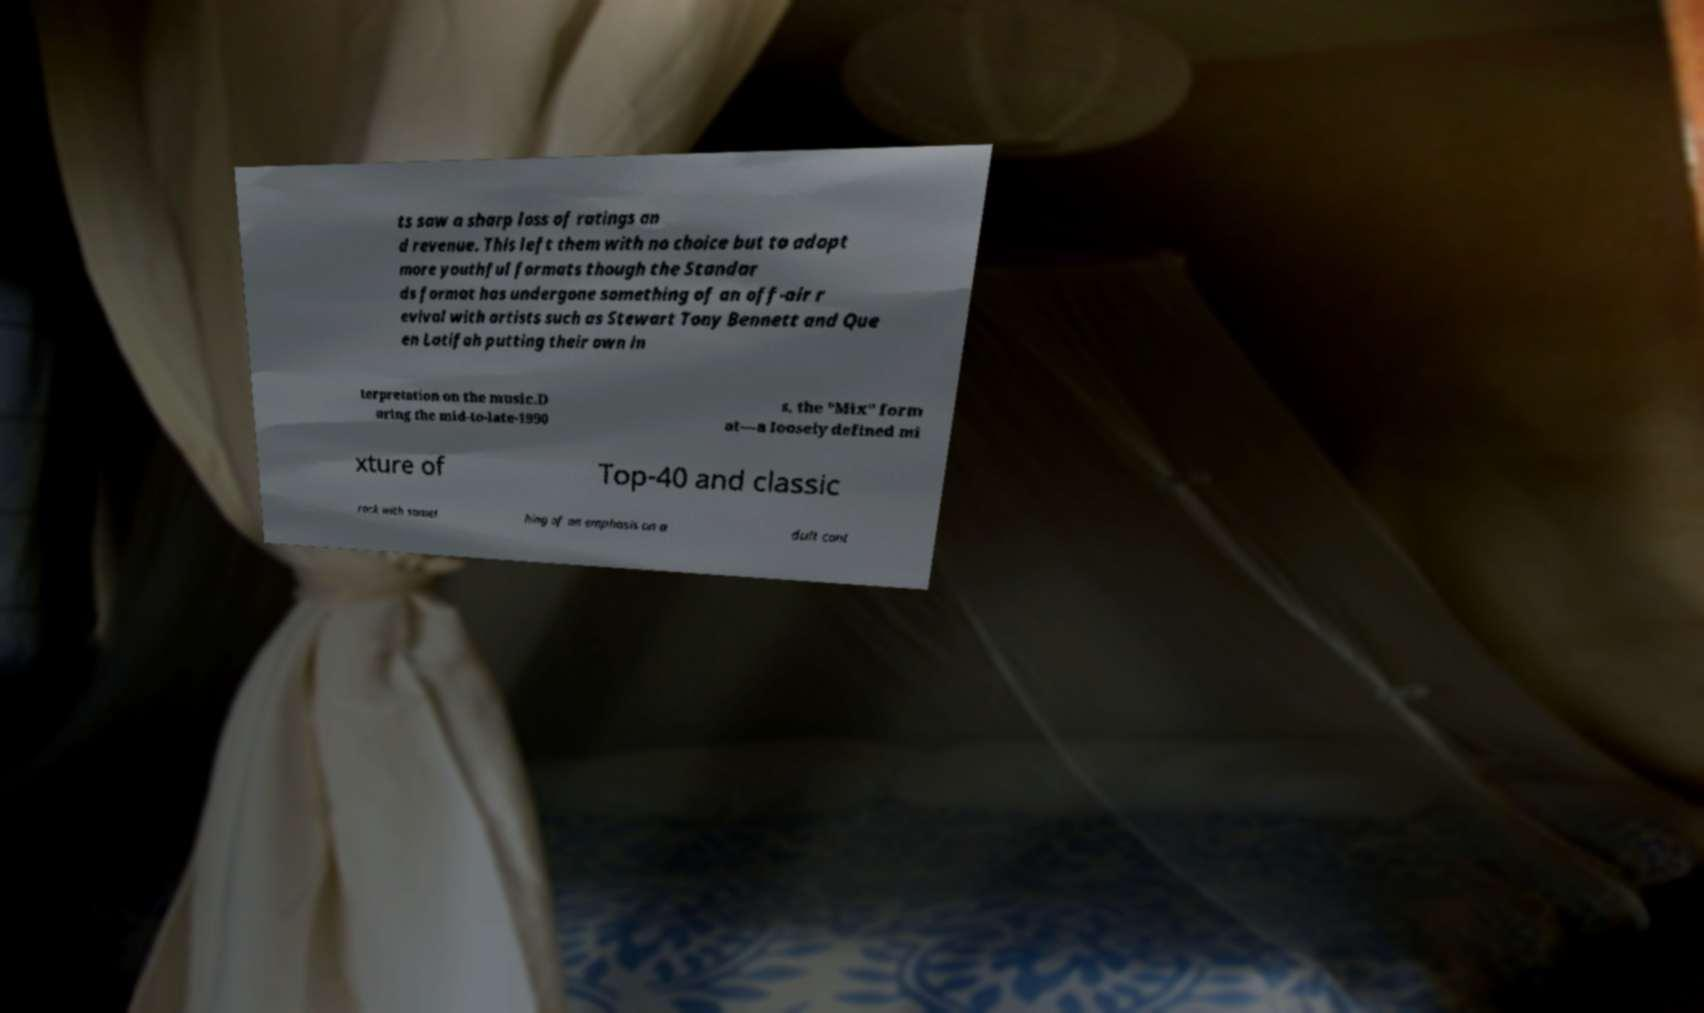What messages or text are displayed in this image? I need them in a readable, typed format. ts saw a sharp loss of ratings an d revenue. This left them with no choice but to adopt more youthful formats though the Standar ds format has undergone something of an off-air r evival with artists such as Stewart Tony Bennett and Que en Latifah putting their own in terpretation on the music.D uring the mid-to-late-1990 s, the "Mix" form at—a loosely defined mi xture of Top-40 and classic rock with somet hing of an emphasis on a dult cont 